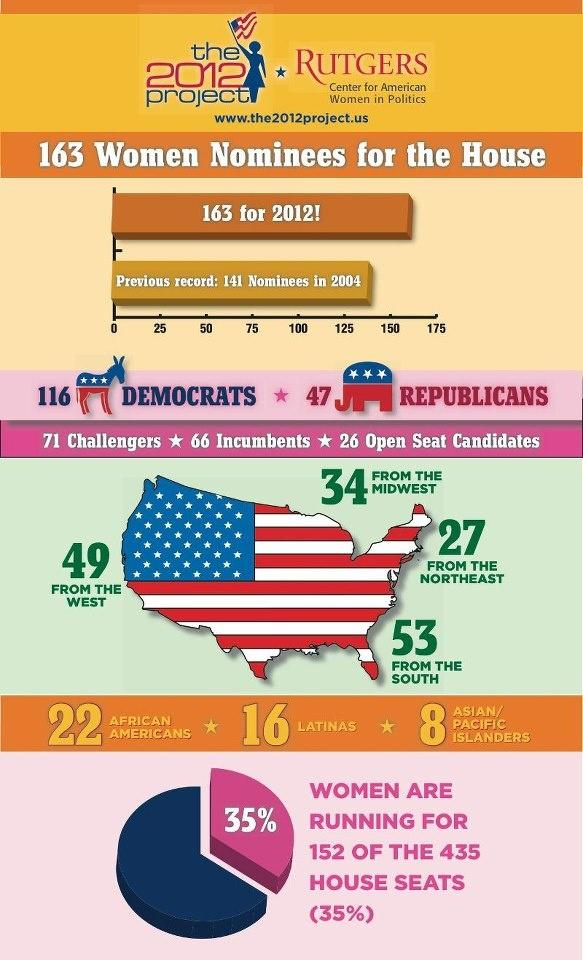Specify some key components in this picture. Of the total number of female nominees, 30 belong to the African American or Asian/Pacific Islander demographic. There are a total of 46 women nominees, who are African Americans, Latinas, or Asian/Pacific islanders. There are a total of 24 women nominees who are African American or Asian/Pacific Islanders. The total number of women nominees from the West and the Midwest is 83. There were a total of 80 women nominees from the North East and the South. 